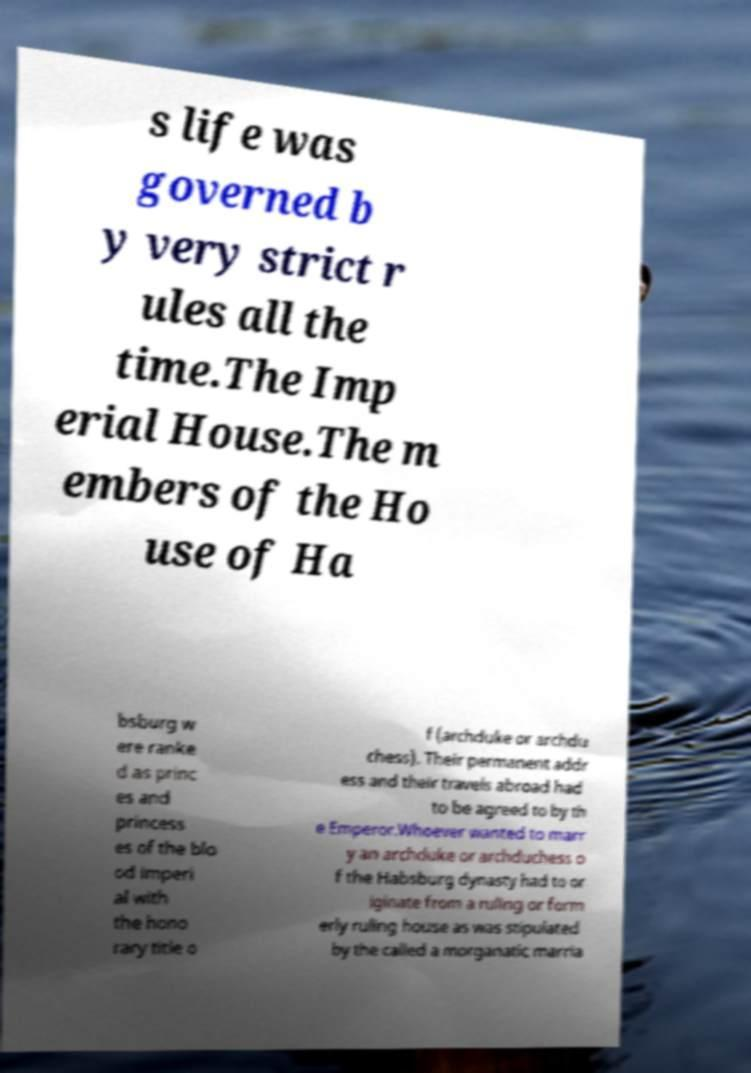There's text embedded in this image that I need extracted. Can you transcribe it verbatim? s life was governed b y very strict r ules all the time.The Imp erial House.The m embers of the Ho use of Ha bsburg w ere ranke d as princ es and princess es of the blo od imperi al with the hono rary title o f (archduke or archdu chess). Their permanent addr ess and their travels abroad had to be agreed to by th e Emperor.Whoever wanted to marr y an archduke or archduchess o f the Habsburg dynasty had to or iginate from a ruling or form erly ruling house as was stipulated by the called a morganatic marria 